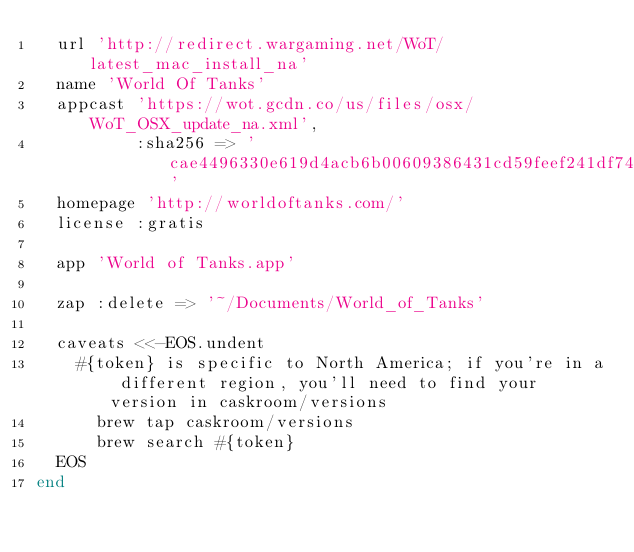<code> <loc_0><loc_0><loc_500><loc_500><_Ruby_>  url 'http://redirect.wargaming.net/WoT/latest_mac_install_na'
  name 'World Of Tanks'
  appcast 'https://wot.gcdn.co/us/files/osx/WoT_OSX_update_na.xml',
          :sha256 => 'cae4496330e619d4acb6b00609386431cd59feef241df74e1a9cb2385ed63000'
  homepage 'http://worldoftanks.com/'
  license :gratis

  app 'World of Tanks.app'

  zap :delete => '~/Documents/World_of_Tanks'

  caveats <<-EOS.undent
    #{token} is specific to North America; if you're in a different region, you'll need to find your version in caskroom/versions
      brew tap caskroom/versions
      brew search #{token}
  EOS
end
</code> 